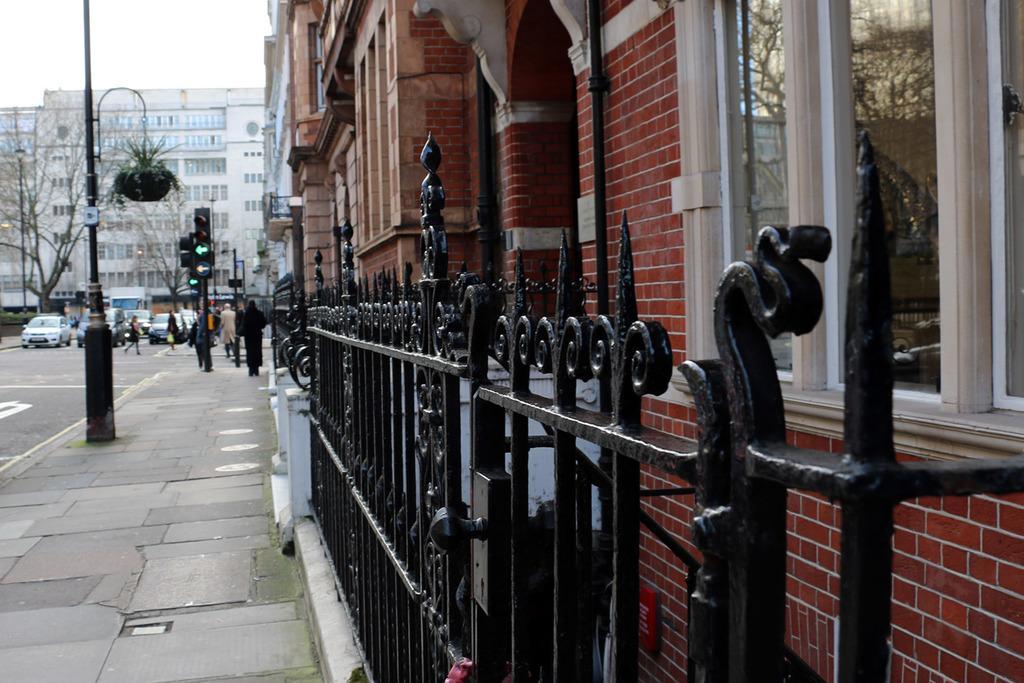Describe this image in one or two sentences. In this image I can see few vehicles and few people on the road. To the side of the road I can see the poles, flower pot and few people In-front of the building. I can also see the black color railing. In the background I can see the building, trees and the sky. 